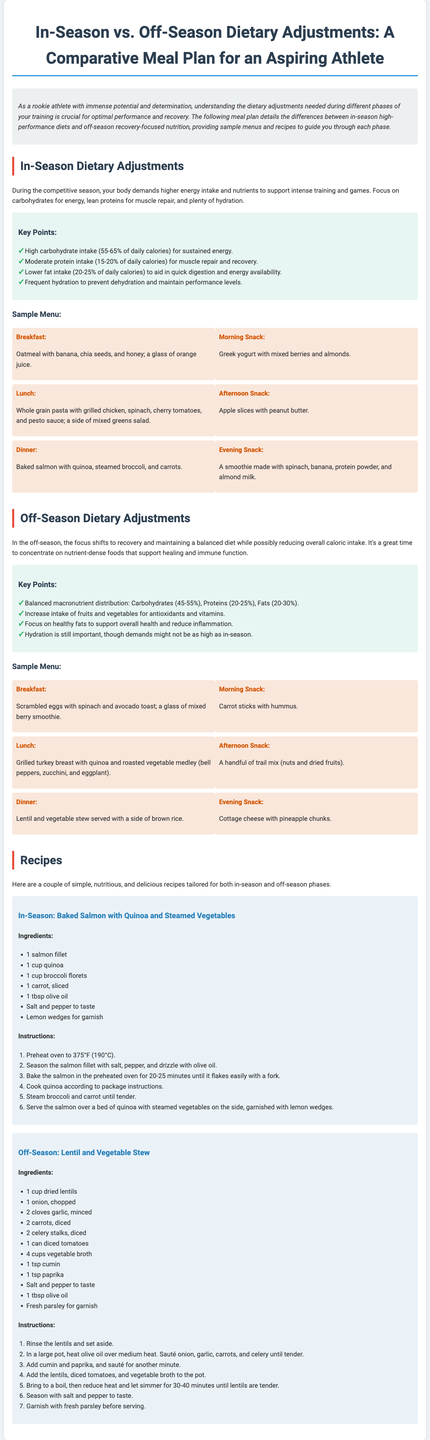What are the macronutrient percentages for in-season diets? In-season diets focus on high carbohydrate intake (55-65%), moderate protein intake (15-20%), and lower fat intake (20-25%).
Answer: 55-65%, 15-20%, 20-25% What is the primary focus of the off-season meal plan? The off-season meal plan primarily focuses on recovery and maintaining a balanced diet while possibly reducing overall caloric intake.
Answer: Recovery What type of fats should be emphasized in the off-season diet? The off-season diet emphasizes healthy fats to support overall health and reduce inflammation.
Answer: Healthy fats What is included in the breakfast for the in-season sample menu? The breakfast includes oatmeal with banana, chia seeds, honey, and a glass of orange juice.
Answer: Oatmeal with banana, chia seeds, honey, and orange juice How much quinoa is used in the in-season salmon recipe? The in-season salmon recipe uses 1 cup of quinoa.
Answer: 1 cup What is the cooking time for the lentil stew? The lentil stew simmers for 30-40 minutes until lentils are tender.
Answer: 30-40 minutes Which meal includes Greek yogurt? The morning snack in the in-season menu includes Greek yogurt with mixed berries and almonds.
Answer: Morning Snack What is the hydration recommendation for in-season athletes? Frequent hydration is recommended to prevent dehydration and maintain performance levels.
Answer: Frequent hydration 